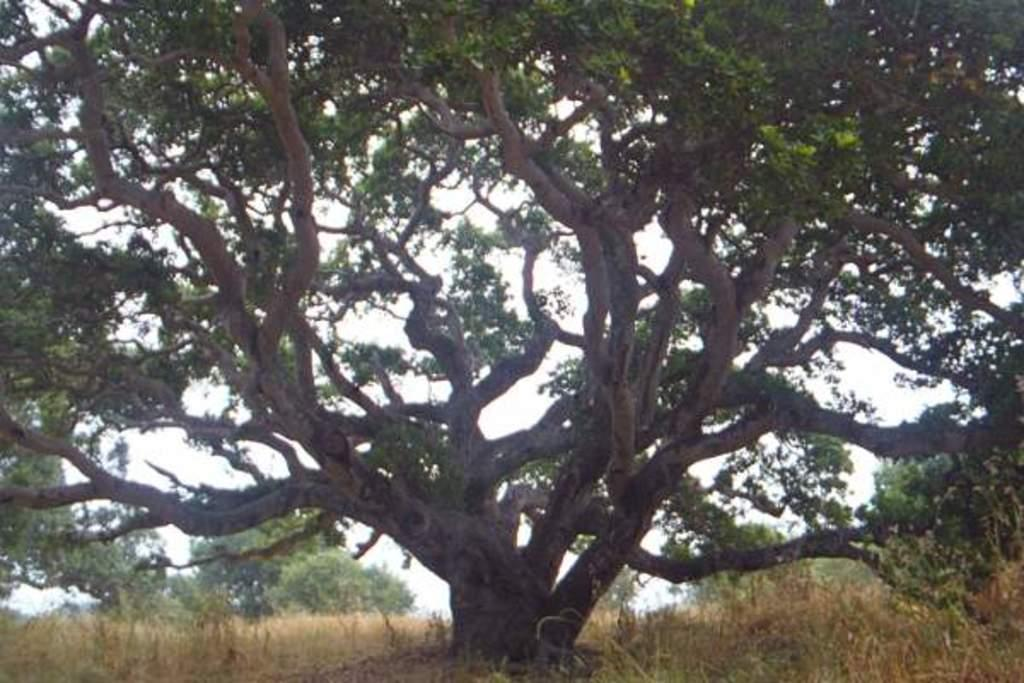What is the main subject in the center of the image? There is a tree in the center of the image. What can be seen in the background of the image? There are plants and trees in the background of the image. What is visible in the sky in the background of the image? The sky is visible in the background of the image. What type of arithmetic problem can be seen written on the tree in the image? There is no arithmetic problem written on the tree in the image. What type of coil is wrapped around the tree in the image? There is no coil wrapped around the tree in the image. 